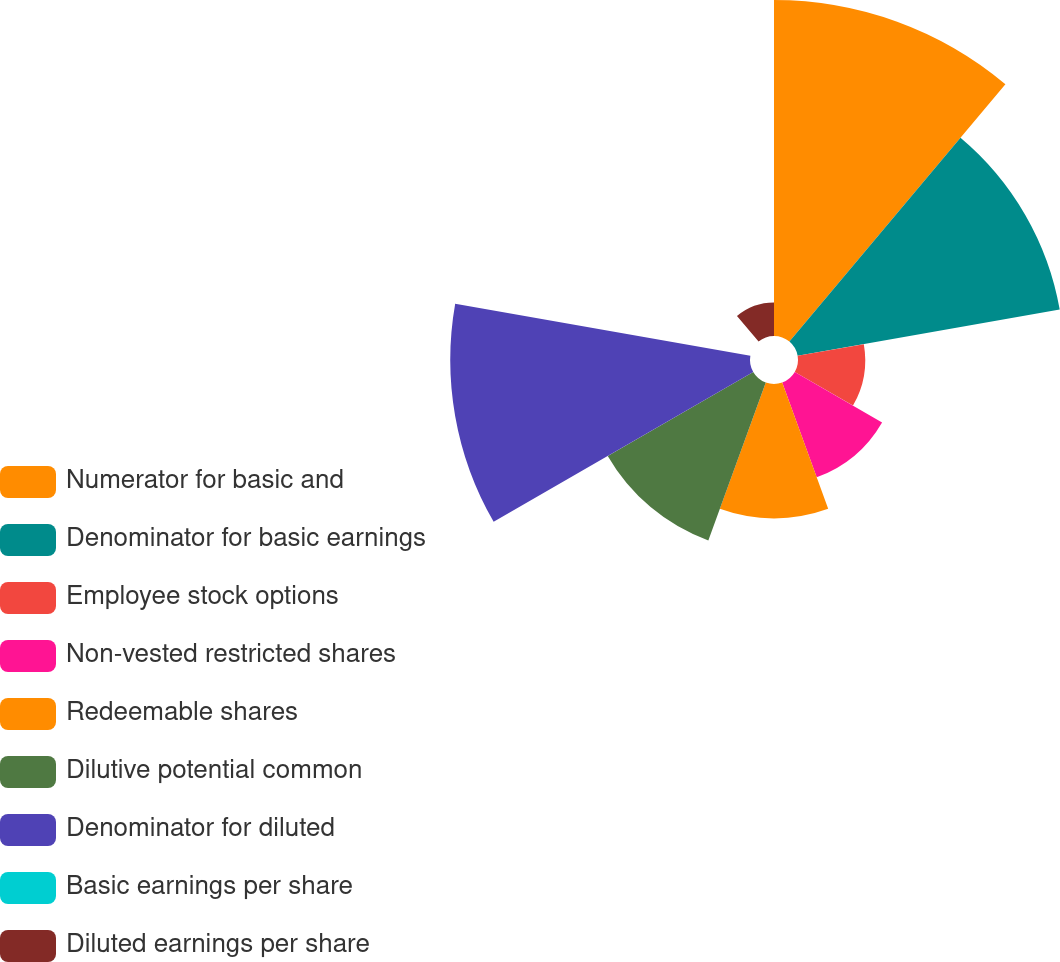Convert chart. <chart><loc_0><loc_0><loc_500><loc_500><pie_chart><fcel>Numerator for basic and<fcel>Denominator for basic earnings<fcel>Employee stock options<fcel>Non-vested restricted shares<fcel>Redeemable shares<fcel>Dilutive potential common<fcel>Denominator for diluted<fcel>Basic earnings per share<fcel>Diluted earnings per share<nl><fcel>23.9%<fcel>18.93%<fcel>4.78%<fcel>7.17%<fcel>9.56%<fcel>11.95%<fcel>21.32%<fcel>0.0%<fcel>2.39%<nl></chart> 